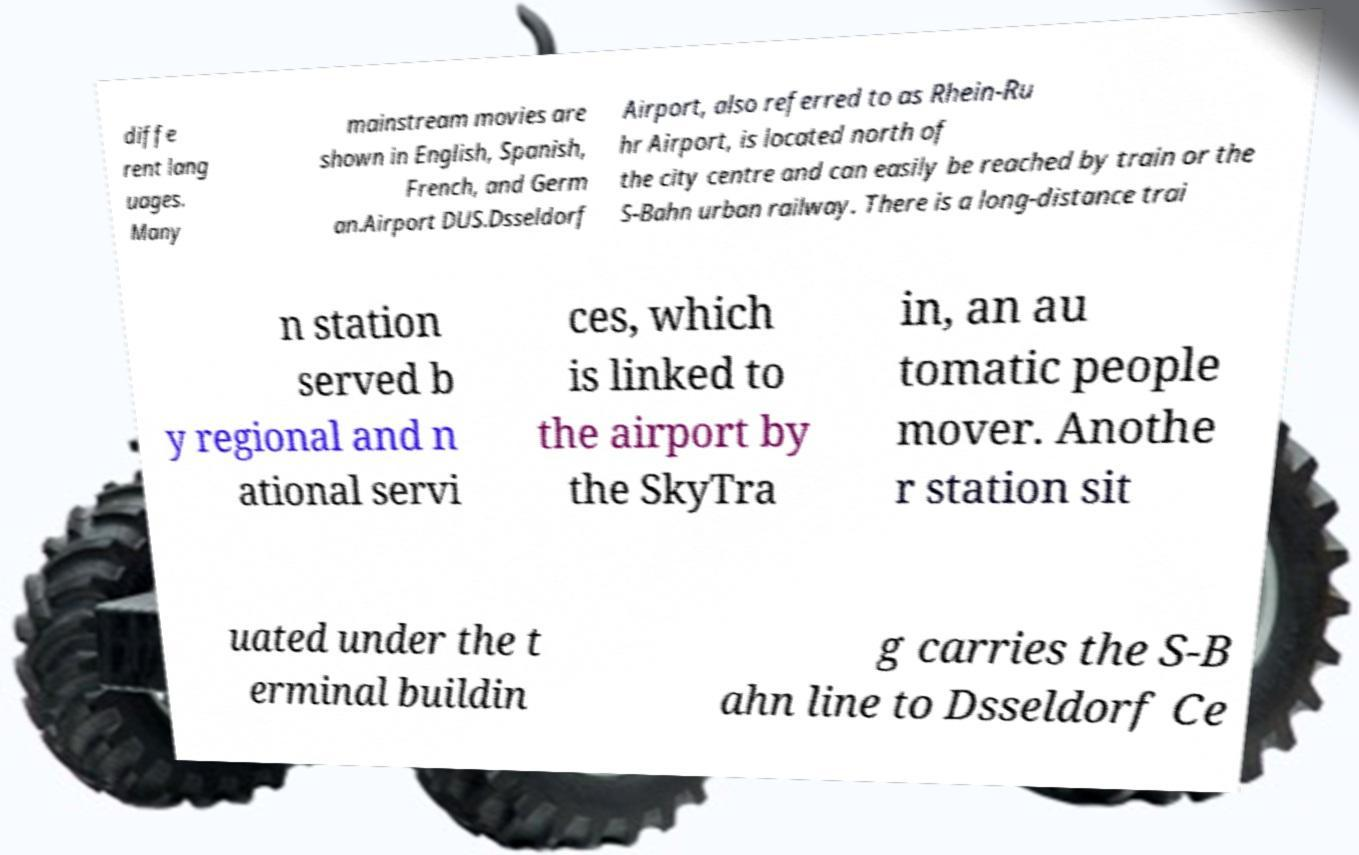There's text embedded in this image that I need extracted. Can you transcribe it verbatim? diffe rent lang uages. Many mainstream movies are shown in English, Spanish, French, and Germ an.Airport DUS.Dsseldorf Airport, also referred to as Rhein-Ru hr Airport, is located north of the city centre and can easily be reached by train or the S-Bahn urban railway. There is a long-distance trai n station served b y regional and n ational servi ces, which is linked to the airport by the SkyTra in, an au tomatic people mover. Anothe r station sit uated under the t erminal buildin g carries the S-B ahn line to Dsseldorf Ce 